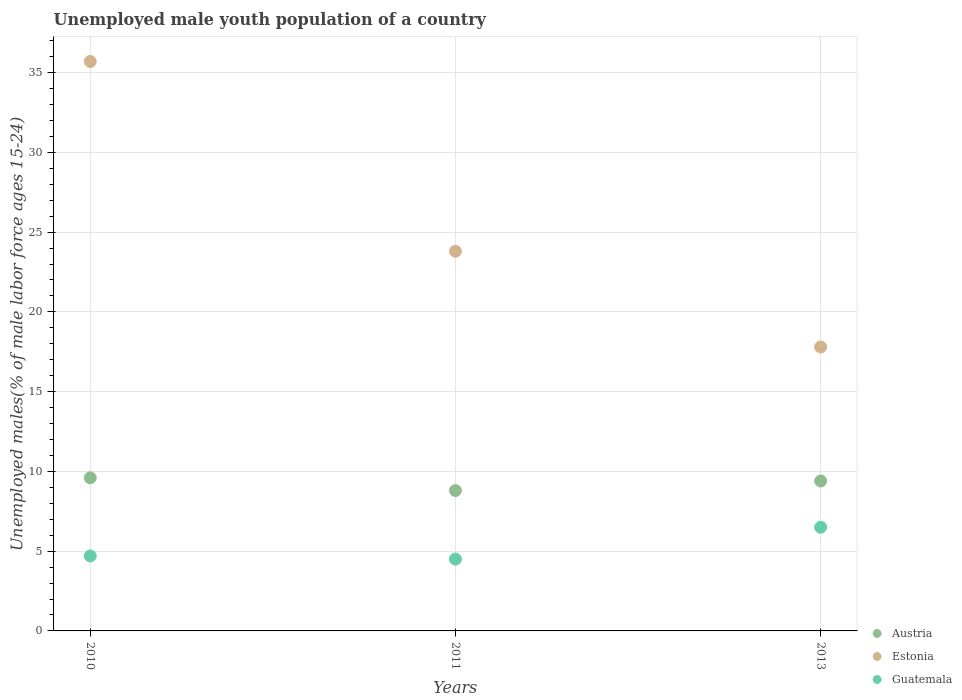What is the percentage of unemployed male youth population in Estonia in 2010?
Ensure brevity in your answer.  35.7. In which year was the percentage of unemployed male youth population in Estonia minimum?
Provide a short and direct response. 2013. What is the total percentage of unemployed male youth population in Guatemala in the graph?
Your response must be concise. 15.7. What is the difference between the percentage of unemployed male youth population in Austria in 2010 and that in 2011?
Your answer should be very brief. 0.8. What is the difference between the percentage of unemployed male youth population in Austria in 2013 and the percentage of unemployed male youth population in Estonia in 2010?
Offer a very short reply. -26.3. What is the average percentage of unemployed male youth population in Austria per year?
Ensure brevity in your answer.  9.27. In the year 2010, what is the difference between the percentage of unemployed male youth population in Austria and percentage of unemployed male youth population in Guatemala?
Keep it short and to the point. 4.9. What is the ratio of the percentage of unemployed male youth population in Estonia in 2010 to that in 2013?
Your answer should be very brief. 2.01. What is the difference between the highest and the second highest percentage of unemployed male youth population in Austria?
Ensure brevity in your answer.  0.2. What is the difference between the highest and the lowest percentage of unemployed male youth population in Estonia?
Provide a succinct answer. 17.9. In how many years, is the percentage of unemployed male youth population in Austria greater than the average percentage of unemployed male youth population in Austria taken over all years?
Offer a terse response. 2. Is the percentage of unemployed male youth population in Austria strictly less than the percentage of unemployed male youth population in Guatemala over the years?
Provide a short and direct response. No. How many years are there in the graph?
Give a very brief answer. 3. What is the difference between two consecutive major ticks on the Y-axis?
Offer a terse response. 5. Does the graph contain grids?
Your answer should be compact. Yes. How are the legend labels stacked?
Offer a terse response. Vertical. What is the title of the graph?
Keep it short and to the point. Unemployed male youth population of a country. Does "Slovak Republic" appear as one of the legend labels in the graph?
Provide a short and direct response. No. What is the label or title of the Y-axis?
Give a very brief answer. Unemployed males(% of male labor force ages 15-24). What is the Unemployed males(% of male labor force ages 15-24) in Austria in 2010?
Ensure brevity in your answer.  9.6. What is the Unemployed males(% of male labor force ages 15-24) in Estonia in 2010?
Make the answer very short. 35.7. What is the Unemployed males(% of male labor force ages 15-24) of Guatemala in 2010?
Offer a very short reply. 4.7. What is the Unemployed males(% of male labor force ages 15-24) in Austria in 2011?
Make the answer very short. 8.8. What is the Unemployed males(% of male labor force ages 15-24) in Estonia in 2011?
Provide a short and direct response. 23.8. What is the Unemployed males(% of male labor force ages 15-24) in Austria in 2013?
Ensure brevity in your answer.  9.4. What is the Unemployed males(% of male labor force ages 15-24) of Estonia in 2013?
Your answer should be very brief. 17.8. What is the Unemployed males(% of male labor force ages 15-24) in Guatemala in 2013?
Provide a short and direct response. 6.5. Across all years, what is the maximum Unemployed males(% of male labor force ages 15-24) of Austria?
Your answer should be compact. 9.6. Across all years, what is the maximum Unemployed males(% of male labor force ages 15-24) of Estonia?
Give a very brief answer. 35.7. Across all years, what is the maximum Unemployed males(% of male labor force ages 15-24) in Guatemala?
Provide a short and direct response. 6.5. Across all years, what is the minimum Unemployed males(% of male labor force ages 15-24) of Austria?
Offer a terse response. 8.8. Across all years, what is the minimum Unemployed males(% of male labor force ages 15-24) in Estonia?
Provide a succinct answer. 17.8. What is the total Unemployed males(% of male labor force ages 15-24) in Austria in the graph?
Your answer should be compact. 27.8. What is the total Unemployed males(% of male labor force ages 15-24) in Estonia in the graph?
Ensure brevity in your answer.  77.3. What is the total Unemployed males(% of male labor force ages 15-24) in Guatemala in the graph?
Keep it short and to the point. 15.7. What is the difference between the Unemployed males(% of male labor force ages 15-24) of Austria in 2010 and that in 2013?
Offer a very short reply. 0.2. What is the difference between the Unemployed males(% of male labor force ages 15-24) of Guatemala in 2011 and that in 2013?
Offer a terse response. -2. What is the difference between the Unemployed males(% of male labor force ages 15-24) in Austria in 2010 and the Unemployed males(% of male labor force ages 15-24) in Estonia in 2011?
Provide a short and direct response. -14.2. What is the difference between the Unemployed males(% of male labor force ages 15-24) in Estonia in 2010 and the Unemployed males(% of male labor force ages 15-24) in Guatemala in 2011?
Ensure brevity in your answer.  31.2. What is the difference between the Unemployed males(% of male labor force ages 15-24) of Austria in 2010 and the Unemployed males(% of male labor force ages 15-24) of Estonia in 2013?
Your answer should be compact. -8.2. What is the difference between the Unemployed males(% of male labor force ages 15-24) of Austria in 2010 and the Unemployed males(% of male labor force ages 15-24) of Guatemala in 2013?
Give a very brief answer. 3.1. What is the difference between the Unemployed males(% of male labor force ages 15-24) of Estonia in 2010 and the Unemployed males(% of male labor force ages 15-24) of Guatemala in 2013?
Offer a very short reply. 29.2. What is the difference between the Unemployed males(% of male labor force ages 15-24) of Austria in 2011 and the Unemployed males(% of male labor force ages 15-24) of Estonia in 2013?
Your answer should be compact. -9. What is the difference between the Unemployed males(% of male labor force ages 15-24) in Estonia in 2011 and the Unemployed males(% of male labor force ages 15-24) in Guatemala in 2013?
Offer a terse response. 17.3. What is the average Unemployed males(% of male labor force ages 15-24) of Austria per year?
Offer a terse response. 9.27. What is the average Unemployed males(% of male labor force ages 15-24) of Estonia per year?
Ensure brevity in your answer.  25.77. What is the average Unemployed males(% of male labor force ages 15-24) in Guatemala per year?
Your response must be concise. 5.23. In the year 2010, what is the difference between the Unemployed males(% of male labor force ages 15-24) in Austria and Unemployed males(% of male labor force ages 15-24) in Estonia?
Make the answer very short. -26.1. In the year 2011, what is the difference between the Unemployed males(% of male labor force ages 15-24) of Austria and Unemployed males(% of male labor force ages 15-24) of Estonia?
Provide a short and direct response. -15. In the year 2011, what is the difference between the Unemployed males(% of male labor force ages 15-24) of Austria and Unemployed males(% of male labor force ages 15-24) of Guatemala?
Make the answer very short. 4.3. In the year 2011, what is the difference between the Unemployed males(% of male labor force ages 15-24) of Estonia and Unemployed males(% of male labor force ages 15-24) of Guatemala?
Offer a terse response. 19.3. In the year 2013, what is the difference between the Unemployed males(% of male labor force ages 15-24) in Austria and Unemployed males(% of male labor force ages 15-24) in Estonia?
Your response must be concise. -8.4. What is the ratio of the Unemployed males(% of male labor force ages 15-24) of Austria in 2010 to that in 2011?
Your answer should be compact. 1.09. What is the ratio of the Unemployed males(% of male labor force ages 15-24) of Estonia in 2010 to that in 2011?
Provide a short and direct response. 1.5. What is the ratio of the Unemployed males(% of male labor force ages 15-24) of Guatemala in 2010 to that in 2011?
Provide a short and direct response. 1.04. What is the ratio of the Unemployed males(% of male labor force ages 15-24) of Austria in 2010 to that in 2013?
Your answer should be very brief. 1.02. What is the ratio of the Unemployed males(% of male labor force ages 15-24) of Estonia in 2010 to that in 2013?
Provide a succinct answer. 2.01. What is the ratio of the Unemployed males(% of male labor force ages 15-24) in Guatemala in 2010 to that in 2013?
Your response must be concise. 0.72. What is the ratio of the Unemployed males(% of male labor force ages 15-24) in Austria in 2011 to that in 2013?
Provide a succinct answer. 0.94. What is the ratio of the Unemployed males(% of male labor force ages 15-24) in Estonia in 2011 to that in 2013?
Your answer should be compact. 1.34. What is the ratio of the Unemployed males(% of male labor force ages 15-24) in Guatemala in 2011 to that in 2013?
Your response must be concise. 0.69. What is the difference between the highest and the second highest Unemployed males(% of male labor force ages 15-24) of Estonia?
Ensure brevity in your answer.  11.9. What is the difference between the highest and the lowest Unemployed males(% of male labor force ages 15-24) in Austria?
Your response must be concise. 0.8. What is the difference between the highest and the lowest Unemployed males(% of male labor force ages 15-24) of Estonia?
Keep it short and to the point. 17.9. 